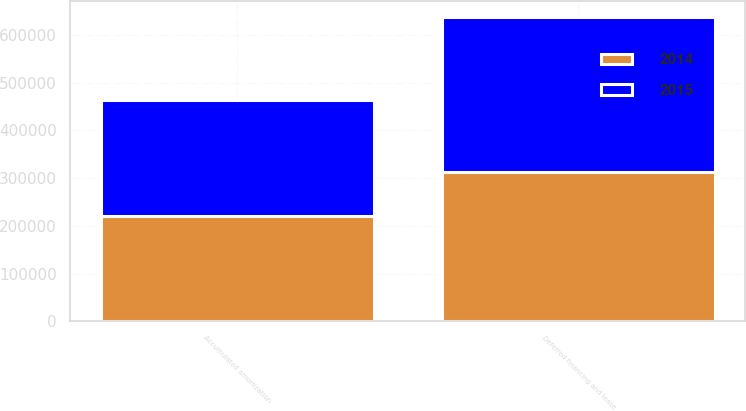<chart> <loc_0><loc_0><loc_500><loc_500><stacked_bar_chart><ecel><fcel>Deferred financing and lease<fcel>Accumulated amortization<nl><fcel>2015<fcel>325720<fcel>242142<nl><fcel>2014<fcel>312569<fcel>220481<nl></chart> 